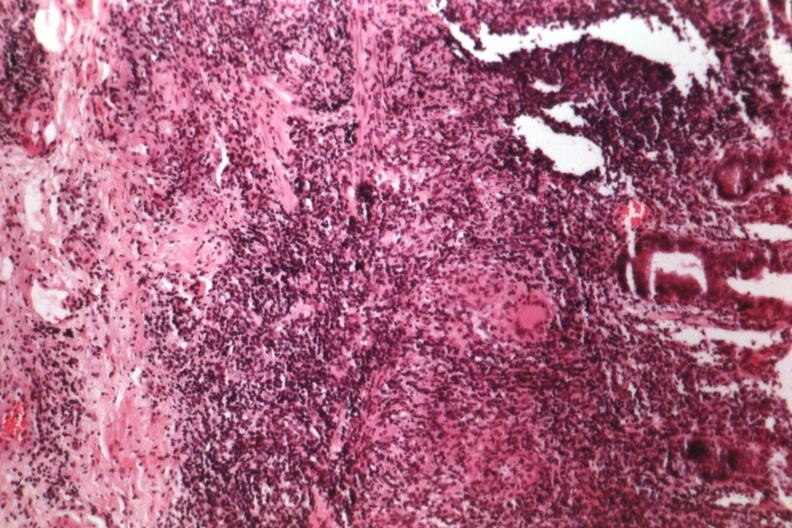where is this from?
Answer the question using a single word or phrase. Gastrointestinal system 